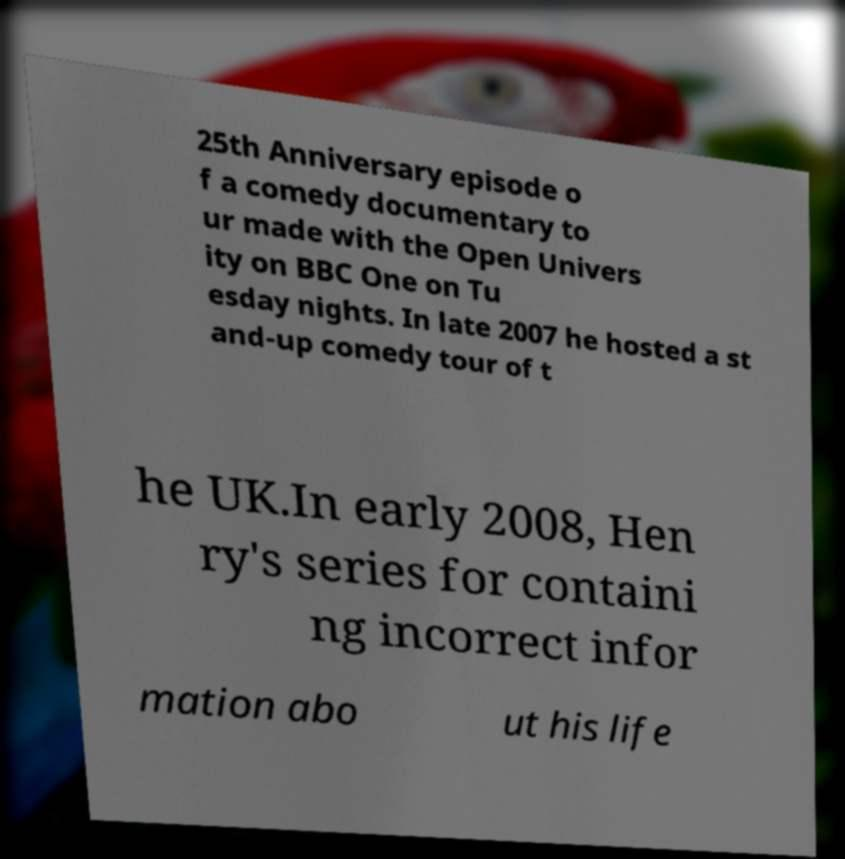Could you extract and type out the text from this image? 25th Anniversary episode o f a comedy documentary to ur made with the Open Univers ity on BBC One on Tu esday nights. In late 2007 he hosted a st and-up comedy tour of t he UK.In early 2008, Hen ry's series for containi ng incorrect infor mation abo ut his life 